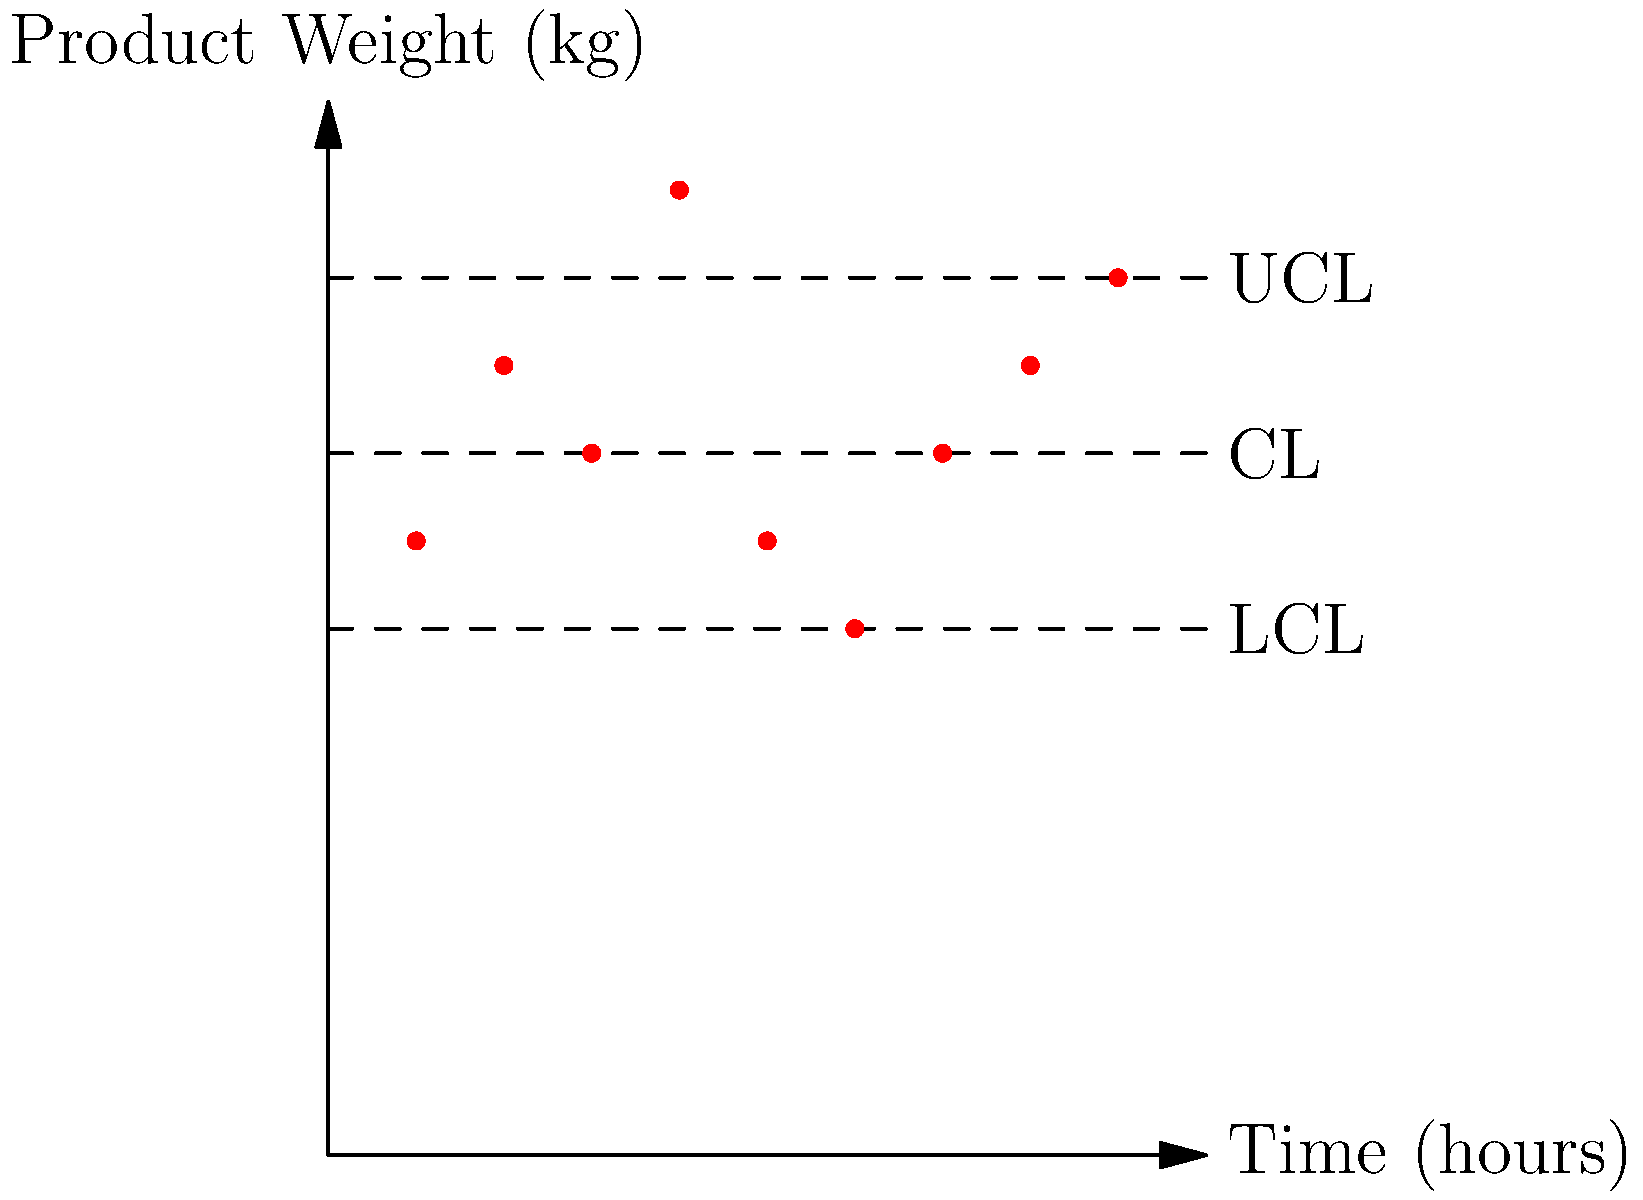As a quality control manager, you're reviewing a product weight control chart for a premium line of packaged goods. The chart shows weight measurements taken hourly over a 9-hour period. Given the Upper Control Limit (UCL) of 10 kg, Lower Control Limit (LCL) of 6 kg, and Central Line (CL) of 8 kg, how many data points indicate a potential quality control issue that requires immediate attention? To answer this question, we need to analyze each data point on the control chart and identify those that fall outside the control limits or show concerning patterns. Let's go through this step-by-step:

1. Understand the control limits:
   - Upper Control Limit (UCL) = 10 kg
   - Lower Control Limit (LCL) = 6 kg
   - Central Line (CL) = 8 kg

2. Analyze each data point:
   Hour 1: Within limits
   Hour 2: Within limits
   Hour 3: Within limits
   Hour 4: Above UCL (11 kg) - Issue
   Hour 5: Within limits
   Hour 6: At LCL (6 kg) - Borderline, but not necessarily an issue
   Hour 7: Within limits
   Hour 8: Within limits
   Hour 9: At UCL (10 kg) - Borderline, but not necessarily an issue

3. Identify patterns:
   - No clear trends or runs are visible
   - No oscillating patterns are present

4. Count points requiring immediate attention:
   Only one point (Hour 4) is clearly outside the control limits, measuring 11 kg, which is above the UCL of 10 kg.

As a discerning buyer who values products that meet strict quality standards, we should focus on clear violations of the control limits. While points at the exact UCL or LCL might warrant monitoring, they don't necessarily require immediate attention.
Answer: 1 data point 